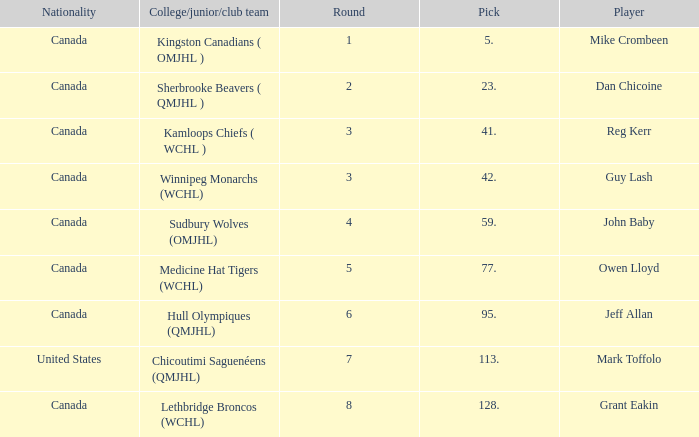Which College/junior/club team has a Round of 2? Sherbrooke Beavers ( QMJHL ). 